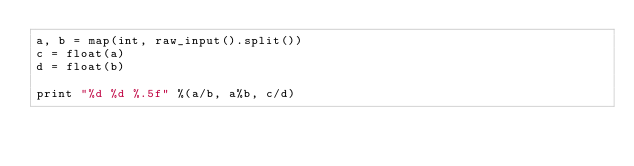<code> <loc_0><loc_0><loc_500><loc_500><_Python_>a, b = map(int, raw_input().split())
c = float(a)
d = float(b)

print "%d %d %.5f" %(a/b, a%b, c/d)</code> 